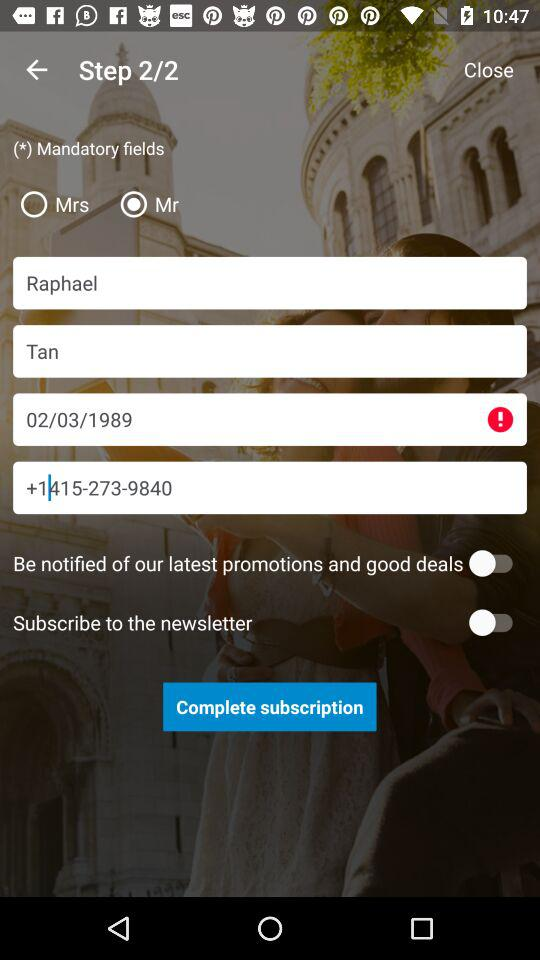At which step am I? You are at step 2. 